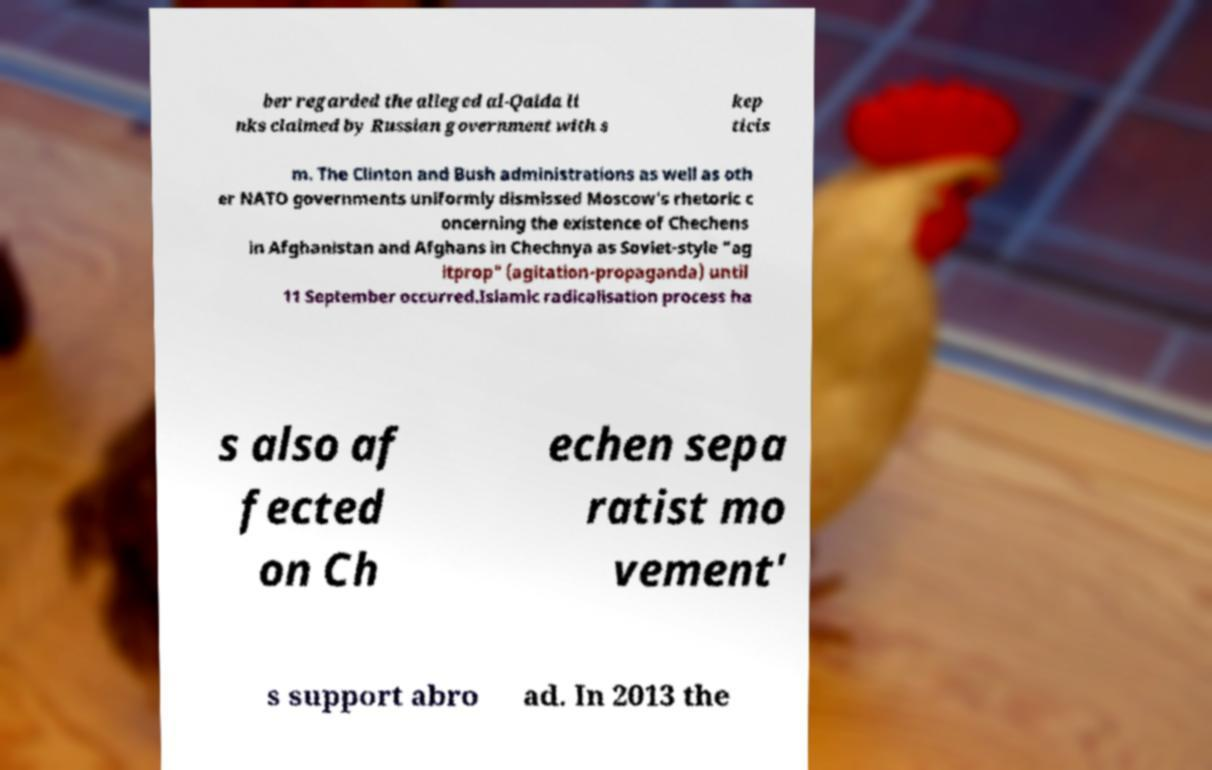Can you accurately transcribe the text from the provided image for me? ber regarded the alleged al-Qaida li nks claimed by Russian government with s kep ticis m. The Clinton and Bush administrations as well as oth er NATO governments uniformly dismissed Moscow's rhetoric c oncerning the existence of Chechens in Afghanistan and Afghans in Chechnya as Soviet-style "ag itprop" (agitation-propaganda) until 11 September occurred.Islamic radicalisation process ha s also af fected on Ch echen sepa ratist mo vement' s support abro ad. In 2013 the 